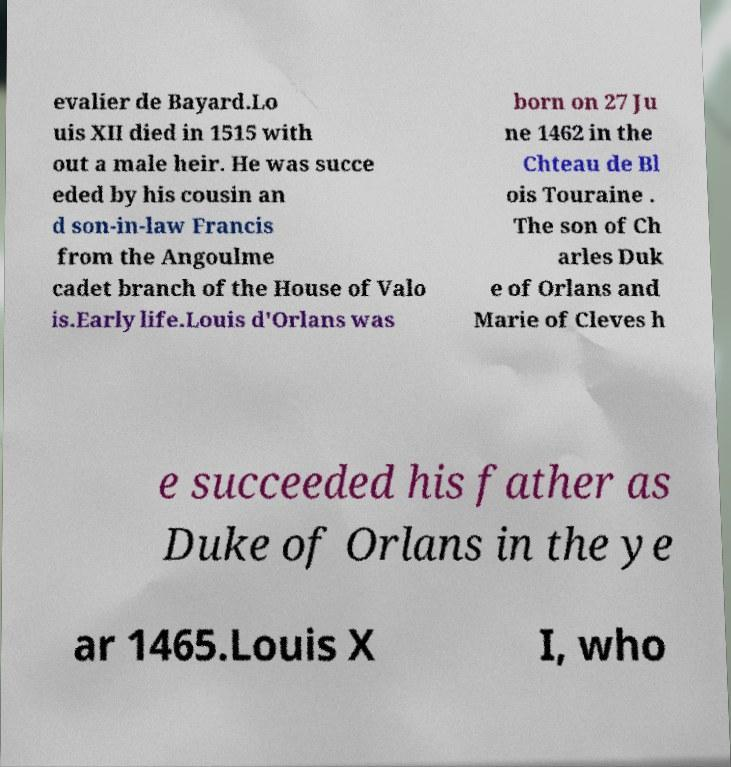Can you accurately transcribe the text from the provided image for me? evalier de Bayard.Lo uis XII died in 1515 with out a male heir. He was succe eded by his cousin an d son-in-law Francis from the Angoulme cadet branch of the House of Valo is.Early life.Louis d'Orlans was born on 27 Ju ne 1462 in the Chteau de Bl ois Touraine . The son of Ch arles Duk e of Orlans and Marie of Cleves h e succeeded his father as Duke of Orlans in the ye ar 1465.Louis X I, who 